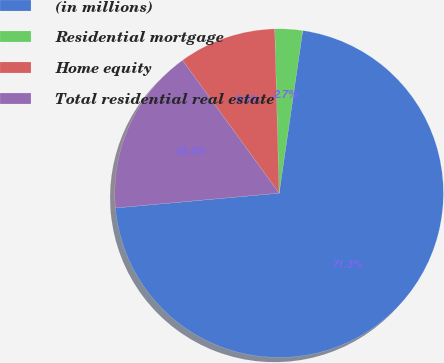<chart> <loc_0><loc_0><loc_500><loc_500><pie_chart><fcel>(in millions)<fcel>Residential mortgage<fcel>Home equity<fcel>Total residential real estate<nl><fcel>71.27%<fcel>2.72%<fcel>9.58%<fcel>16.43%<nl></chart> 